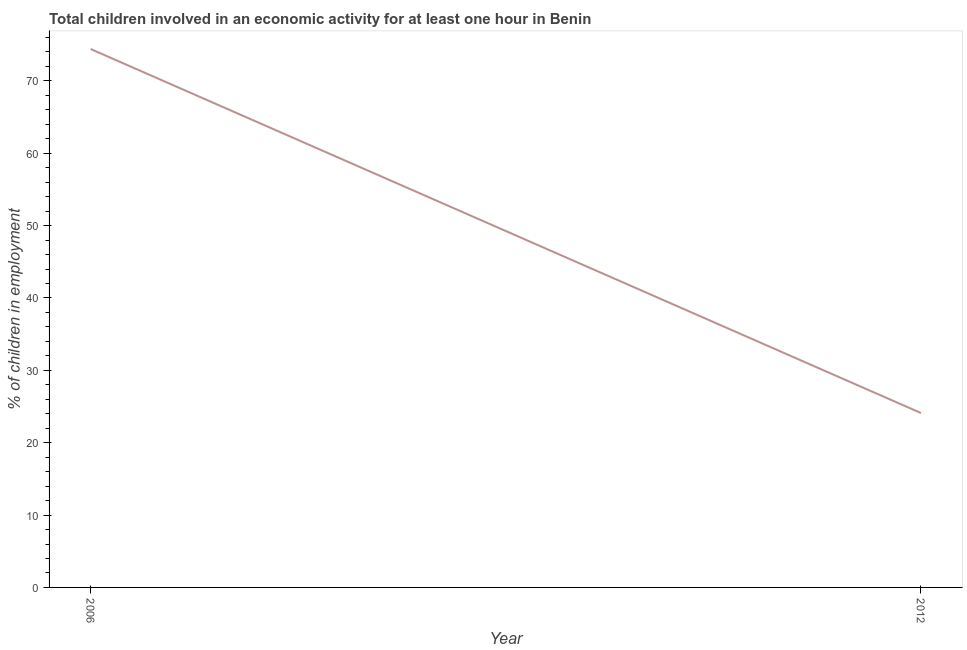What is the percentage of children in employment in 2012?
Your answer should be very brief. 24.1. Across all years, what is the maximum percentage of children in employment?
Offer a terse response. 74.4. Across all years, what is the minimum percentage of children in employment?
Your answer should be compact. 24.1. In which year was the percentage of children in employment minimum?
Your response must be concise. 2012. What is the sum of the percentage of children in employment?
Make the answer very short. 98.5. What is the difference between the percentage of children in employment in 2006 and 2012?
Offer a very short reply. 50.3. What is the average percentage of children in employment per year?
Give a very brief answer. 49.25. What is the median percentage of children in employment?
Make the answer very short. 49.25. Do a majority of the years between 2006 and 2012 (inclusive) have percentage of children in employment greater than 40 %?
Provide a short and direct response. No. What is the ratio of the percentage of children in employment in 2006 to that in 2012?
Keep it short and to the point. 3.09. What is the title of the graph?
Give a very brief answer. Total children involved in an economic activity for at least one hour in Benin. What is the label or title of the X-axis?
Your response must be concise. Year. What is the label or title of the Y-axis?
Make the answer very short. % of children in employment. What is the % of children in employment of 2006?
Your answer should be compact. 74.4. What is the % of children in employment in 2012?
Your answer should be very brief. 24.1. What is the difference between the % of children in employment in 2006 and 2012?
Your response must be concise. 50.3. What is the ratio of the % of children in employment in 2006 to that in 2012?
Your response must be concise. 3.09. 